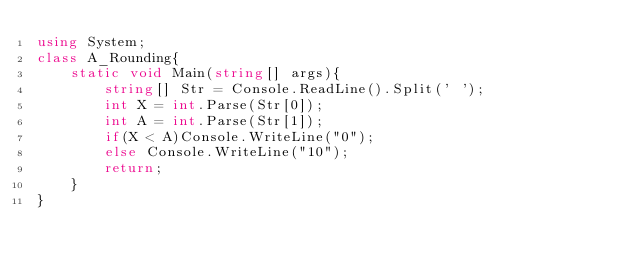<code> <loc_0><loc_0><loc_500><loc_500><_C#_>using System;
class A_Rounding{
	static void Main(string[] args){
		string[] Str = Console.ReadLine().Split(' ');
		int X = int.Parse(Str[0]);
		int A = int.Parse(Str[1]);
		if(X < A)Console.WriteLine("0");
		else Console.WriteLine("10");
		return;
	}
}</code> 